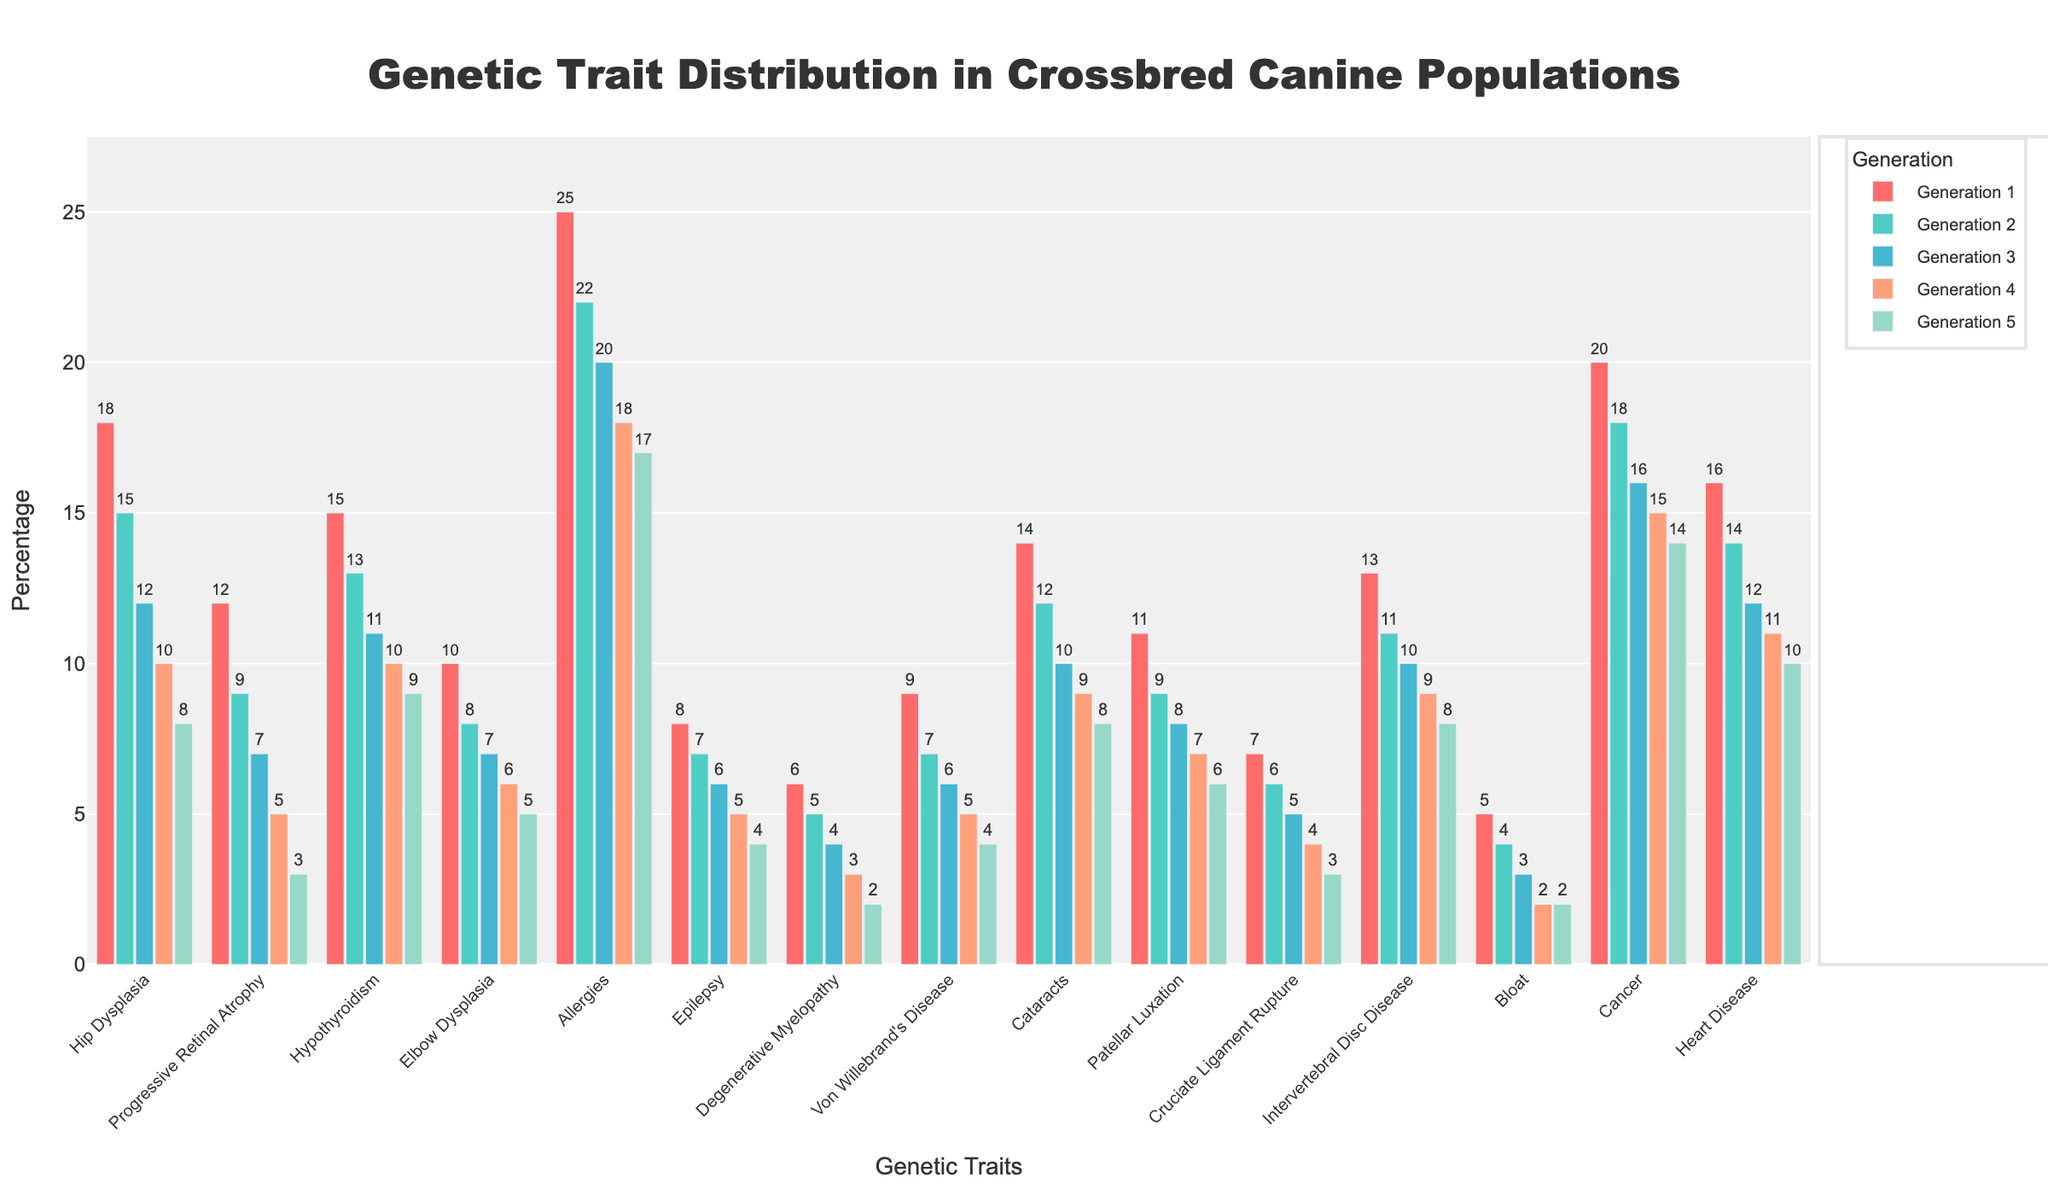What is the trait with the highest percentage in Generation 1? Look at the bar heights for Generation 1 and identify the tallest bar. The tallest bar in Generation 1 is for "Allergies" at 25%.
Answer: Allergies Which generation shows the lowest percentage for Hip Dysplasia? Examine the bar heights for Hip Dysplasia across all generations and identify the shortest bar. The shortest bar is in Generation 5 with 8%.
Answer: Generation 5 How does the percentage of Progressive Retinal Atrophy change from Generation 1 to Generation 3? Calculate the difference between the percentage in Generation 1 (12%) and Generation 3 (7%). Subtracting these values, 12% - 7% = 5%.
Answer: Decreases by 5% Compare the percentage of Cancer in Generation 2 with Hypothyroidism in Generation 3. Which one is higher? Look at the bar heights for Cancer in Generation 2 (18%) and Hypothyroidism in Generation 3 (11%) and compare them. Cancer in Generation 2 is higher.
Answer: Cancer in Generation 2 What is the average percentage of Elbow Dysplasia across all generations? Add the percentages for Elbow Dysplasia across all generations (10%, 8%, 7%, 6%, 5%) and divide by 5. (10 + 8 + 7 + 6 + 5) / 5 = 36 / 5 = 7.2%.
Answer: 7.2% Which traits show a consistent decrease in percentage from Generation 1 to Generation 5? Look at the trends for all traits from Generation 1 to Generation 5 and identify those with a regular decrease. Examples include Hip Dysplasia, Progressive Retinal Atrophy, Epilepsy, etc.
Answer: Hip Dysplasia, Progressive Retinal Atrophy, Epilepsy.. What is the total percentage decrease for Heart Disease from Generation 1 to Generation 5? Calculate the difference between Generation 1 (16%) and Generation 5 (10%), then subtract: 16% - 10% = 6%.
Answer: 6% How does Patellar Luxation in Generation 2 compare visually to Degenerative Myelopathy in Generation 4? Compare the bar heights for Patellar Luxation in Generation 2 (9%) and Degenerative Myelopathy in Generation 4 (3%). Patellar Luxation in Generation 2 is higher.
Answer: Patellar Luxation in Generation 2 is higher What is the sum of percentages for Cancer across all generations? Add the percentages for Cancer from all generations (20%, 18%, 16%, 15%, 14%). 20 + 18 + 16 + 15 + 14 = 83%.
Answer: 83% Which trait shows the smallest percentage decrease from Generation 1 to Generation 5? Compare the decrease in percentages for each trait by subtracting values in Generation 5 from Generation 1 and find the smallest difference. Allergies: 25% - 17% = 8%.
Answer: Allergies 